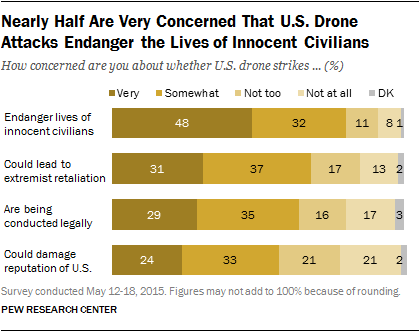List a handful of essential elements in this visual. According to the survey, out of all the options presented, only two options have over 30% of respondents who voted very concerned. There are four options featured in the chart. 